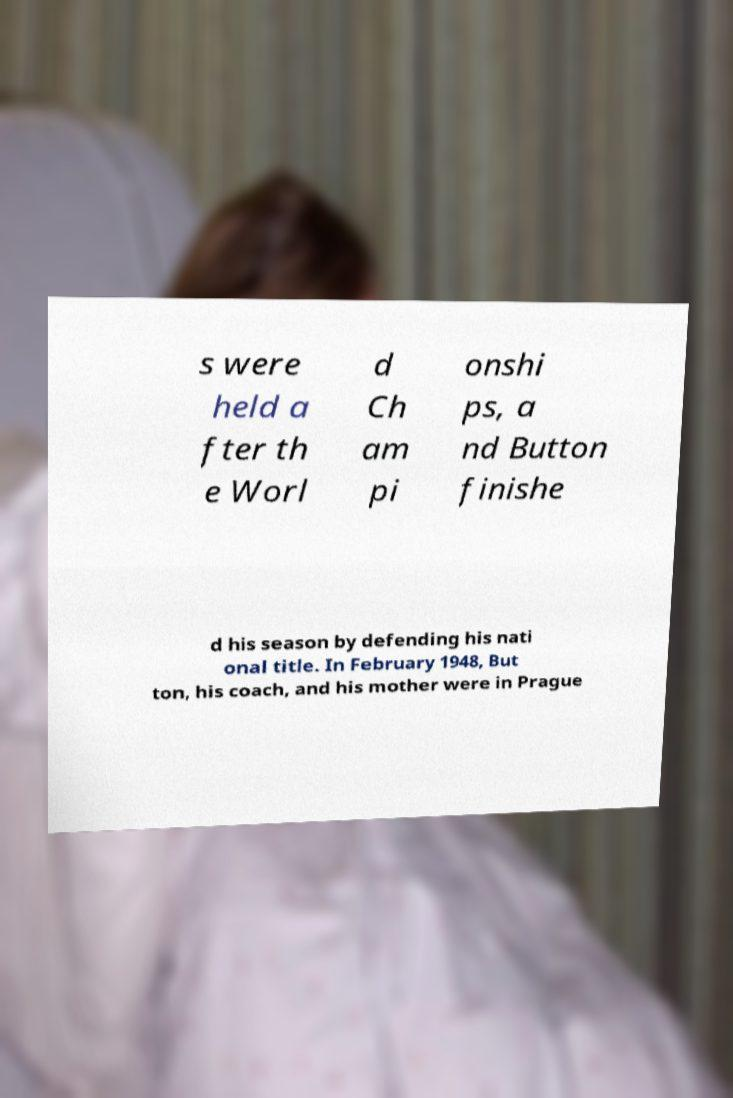Could you assist in decoding the text presented in this image and type it out clearly? s were held a fter th e Worl d Ch am pi onshi ps, a nd Button finishe d his season by defending his nati onal title. In February 1948, But ton, his coach, and his mother were in Prague 